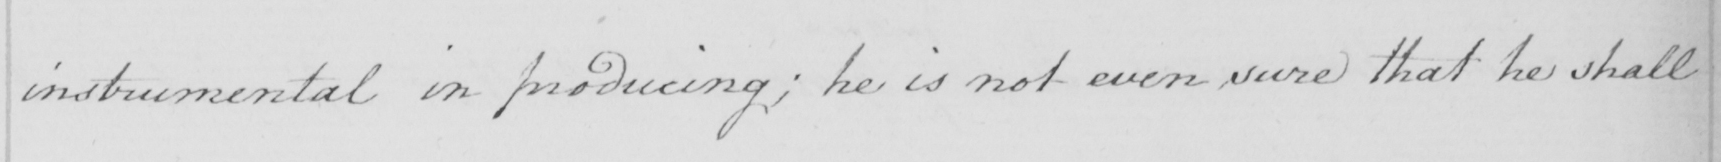Please provide the text content of this handwritten line. instrumental in producing ; he is not even sure that he shall 